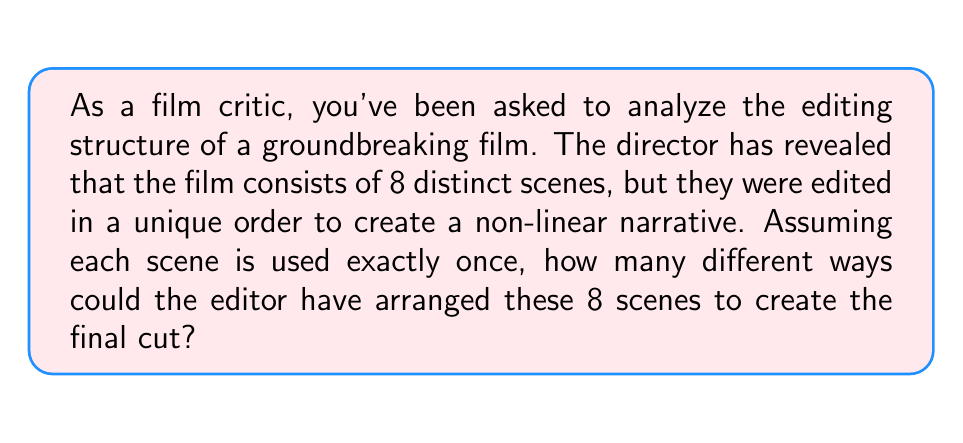What is the answer to this math problem? To solve this problem, we need to understand the concept of permutations in Group theory. In this case, we are dealing with a permutation of 8 distinct objects (scenes), where each scene is used exactly once and the order matters.

The number of permutations of n distinct objects is given by the factorial of n, denoted as n!

For this problem:
1. We have 8 distinct scenes.
2. Each scene is used exactly once.
3. The order of scenes matters.

Therefore, we can calculate the number of unique permutations as follows:

$$8! = 8 \times 7 \times 6 \times 5 \times 4 \times 3 \times 2 \times 1$$

Let's break this down step-by-step:

1. For the first position, we have 8 choices.
2. For the second position, we have 7 remaining choices.
3. For the third position, we have 6 remaining choices.
4. This continues until we have only 1 choice for the last position.

Multiplying these numbers together gives us the total number of possible arrangements:

$$8! = 8 \times 7 \times 6 \times 5 \times 4 \times 3 \times 2 \times 1 = 40,320$$

This large number demonstrates the vast creative possibilities available to film editors when arranging scenes, which can significantly impact the narrative structure and viewer experience.
Answer: $40,320$ 